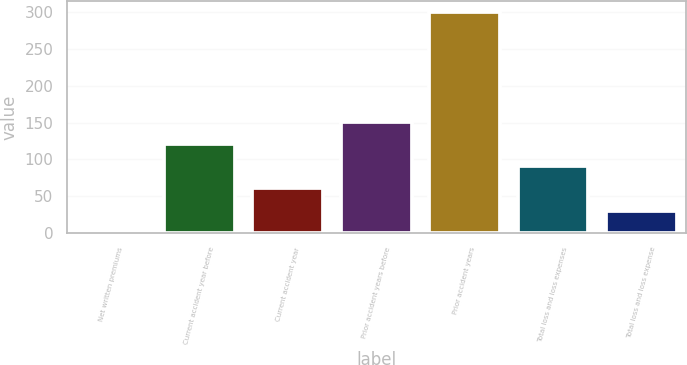Convert chart. <chart><loc_0><loc_0><loc_500><loc_500><bar_chart><fcel>Net written premiums<fcel>Current accident year before<fcel>Current accident year<fcel>Prior accident years before<fcel>Prior accident years<fcel>Total loss and loss expenses<fcel>Total loss and loss expense<nl><fcel>1<fcel>120.6<fcel>60.8<fcel>150.5<fcel>300<fcel>90.7<fcel>30.9<nl></chart> 